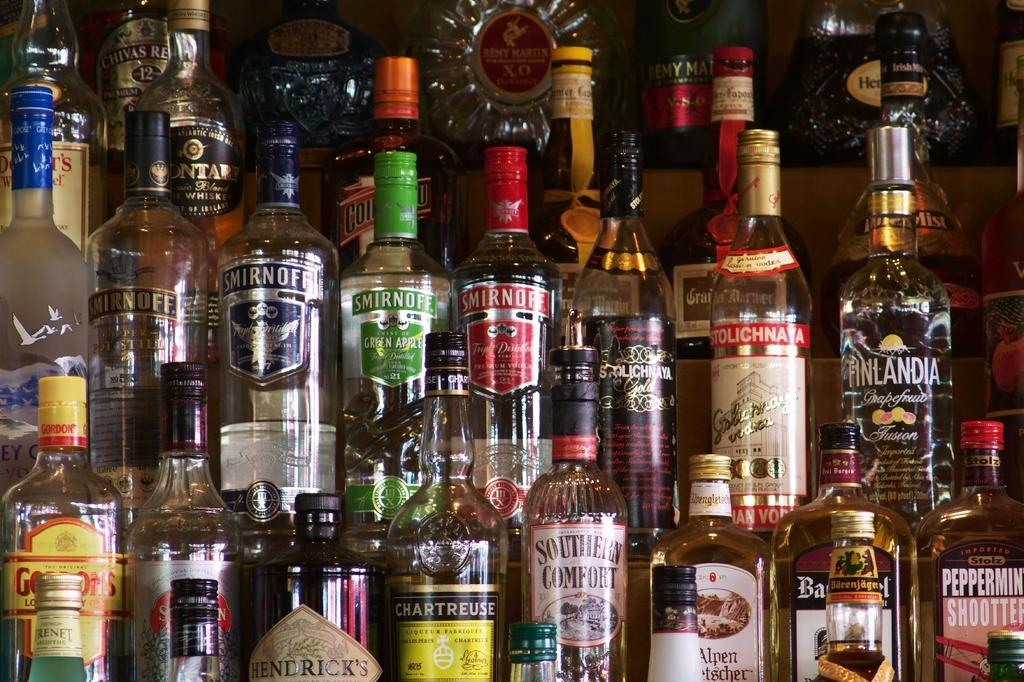<image>
Summarize the visual content of the image. Many bottles of liquor stacked on shelves, including Smirnoff Green Apple, Smirnoff Premium Vodka, and Southern Comfort. 